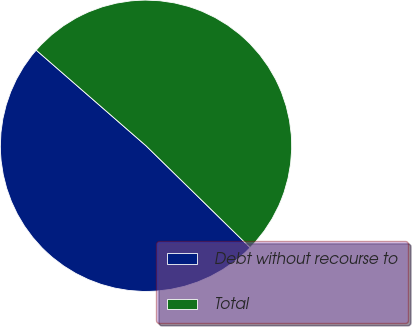<chart> <loc_0><loc_0><loc_500><loc_500><pie_chart><fcel>Debt without recourse to<fcel>Total<nl><fcel>49.08%<fcel>50.92%<nl></chart> 